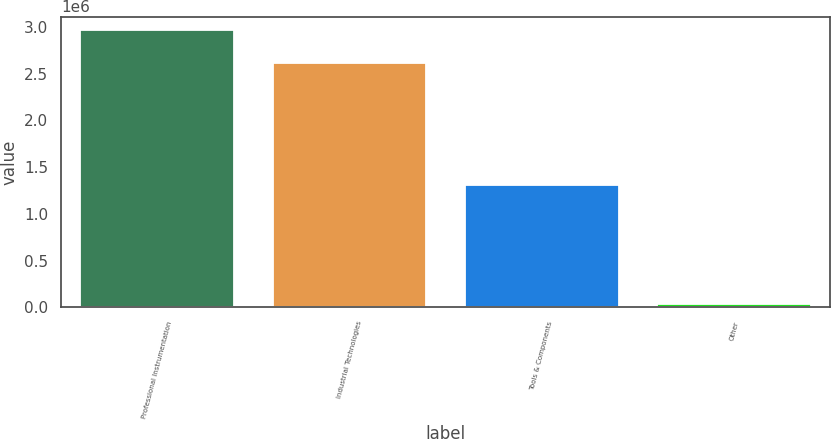Convert chart to OTSL. <chart><loc_0><loc_0><loc_500><loc_500><bar_chart><fcel>Professional Instrumentation<fcel>Industrial Technologies<fcel>Tools & Components<fcel>Other<nl><fcel>2.96355e+06<fcel>2.6195e+06<fcel>1.30626e+06<fcel>30644<nl></chart> 